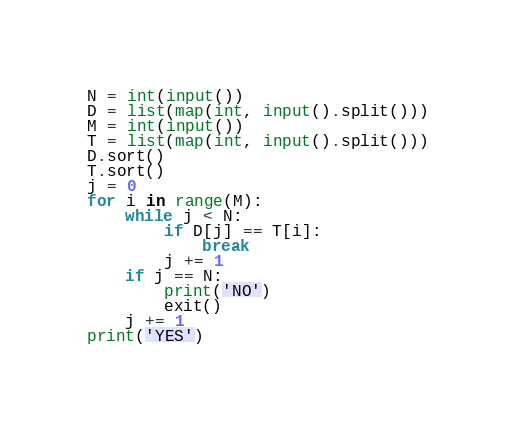<code> <loc_0><loc_0><loc_500><loc_500><_Python_>N = int(input())
D = list(map(int, input().split()))
M = int(input())
T = list(map(int, input().split()))
D.sort()
T.sort()
j = 0
for i in range(M):
    while j < N:
        if D[j] == T[i]:
            break
        j += 1
    if j == N:
        print('NO')
        exit()
    j += 1
print('YES')
</code> 